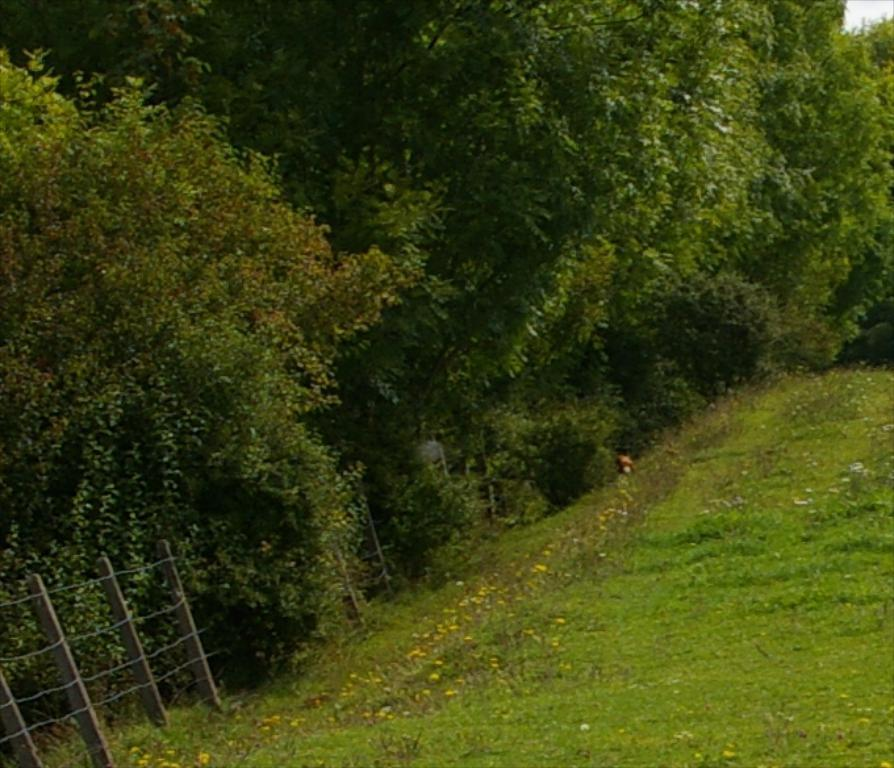What type of structure is located on the left side of the image? There is an iron fencing on the left side of the image. What type of natural elements can be seen in the image? There are trees in the image. What type of plants are present at the bottom of the image? Flower plants are present at the bottom of the image. What type of fowl can be seen perched on the iron fencing in the image? There are no fowl present in the image; it only features an iron fencing, trees, and flower plants. What time of day is depicted in the image? The time of day cannot be determined from the image, as there are no specific indicators of time present. 